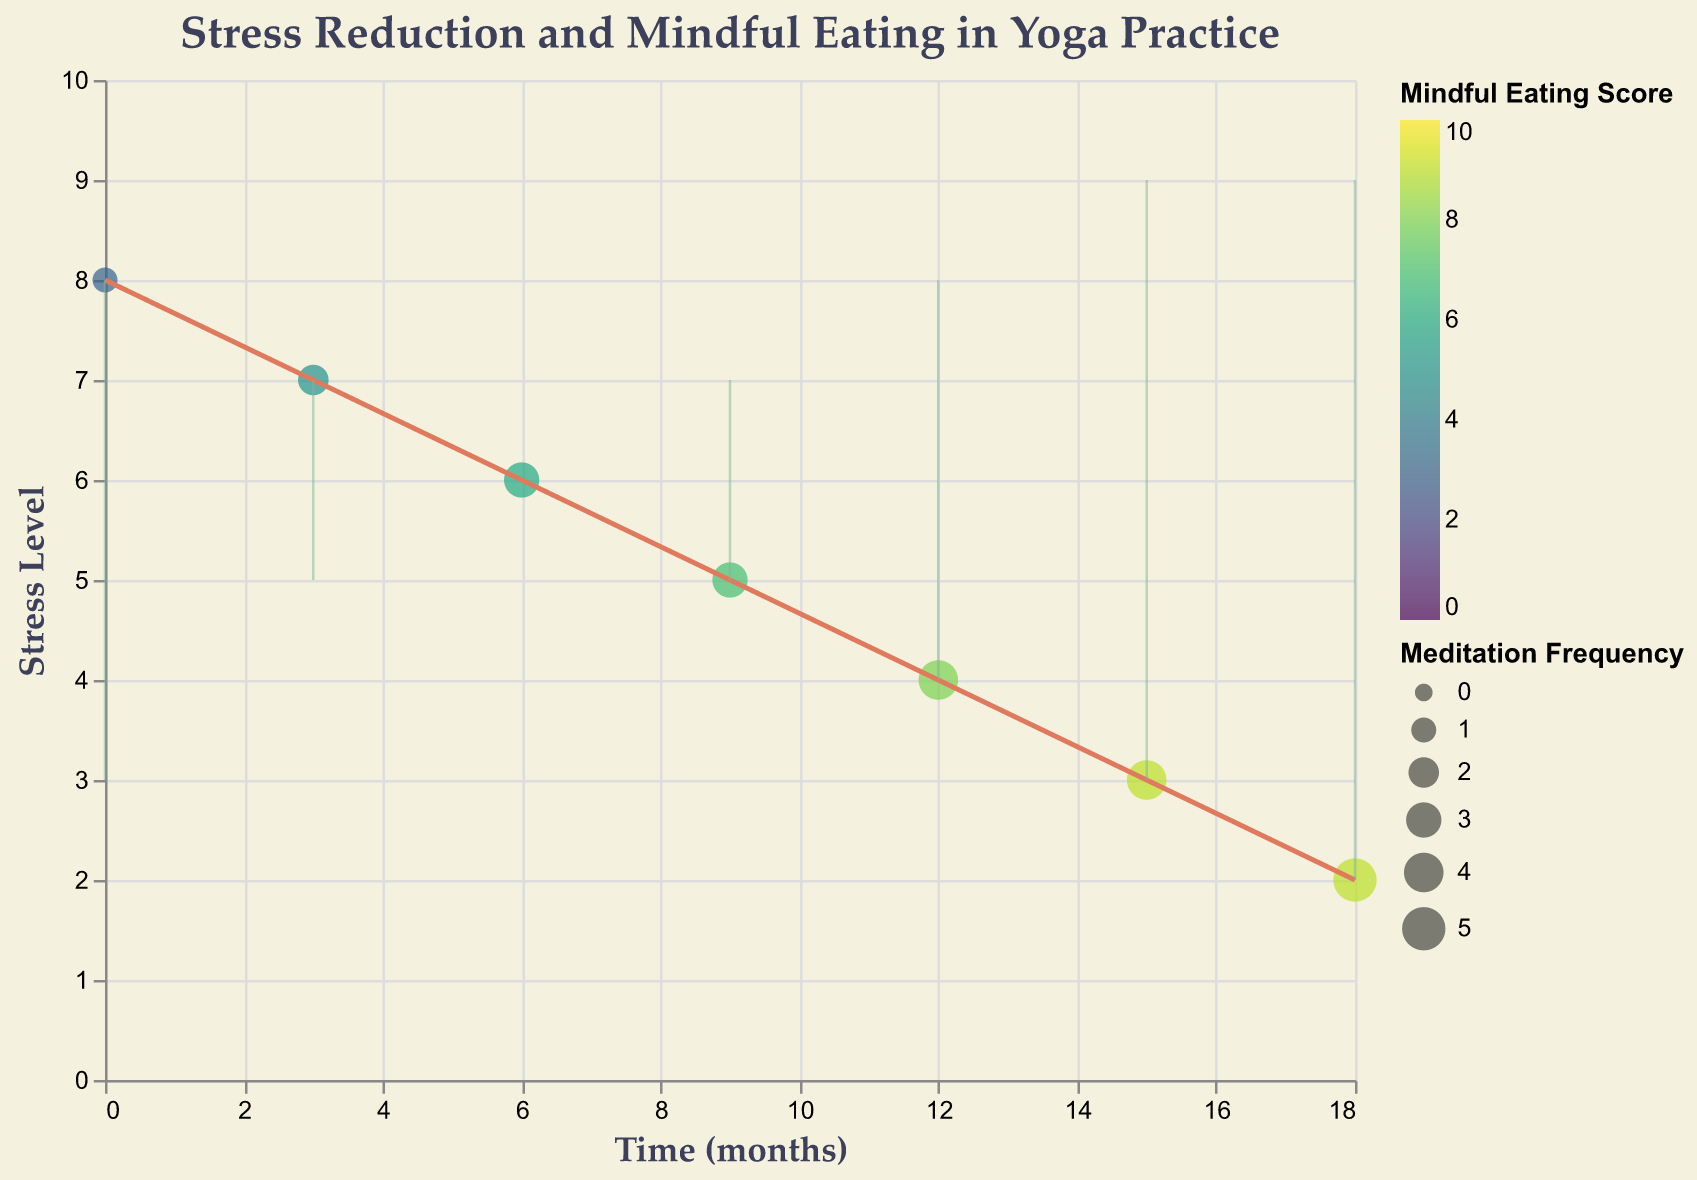How does the title describe the main focus of the figure? The title "Stress Reduction and Mindful Eating in Yoga Practice" indicates that the plot is about examining the relationship between stress reduction and mindful eating habits among yoga practitioners over time.
Answer: The relationship between stress reduction and mindful eating What is displayed along the x-axis? The x-axis represents the "Time (months)" over which the data was collected.
Answer: Time (months) What is the range of the stress level on the y-axis? The y-axis shows "Stress Level," ranging from 0 to 10 based on the axis labels.
Answer: 0 to 10 How does the color scheme relate to the Mindful Eating Score? The color scheme, ranging from lighter to darker shades, reflects the "Mindful Eating Score" from low to high, as per the legend.
Answer: It shows the Mindful Eating Score What does the size of the points indicate? The size of the points indicates the "Meditation Frequency (times/week)" with larger points representing higher frequency according to the legend.
Answer: Meditation Frequency Between which months did the stress level decrease the most significantly? The stress level dropped from 3 months (stress level 7) to 6 months (stress level 6), and from 12 months (stress level 4) to 15 months (stress level 3), both by 1 point each.
Answer: 3 to 6 months and 12 to 15 months How does the stress level at 18 months compare to the beginning (0 months)? At 18 months, the stress level is 2, which has significantly reduced from the stress level of 8 at 0 months.
Answer: 2 vs. 8 Which month had the highest Mindful Eating Score, and what was the corresponding stress level? At 15 and 18 months, the Mindful Eating Score was highest at 9, with corresponding stress levels of 3 and 2, respectively.
Answer: 15 and 18 months: Stress levels 3 and 2 What trend do you observe in the Cortisol Reduction percentage over time? The Cortisol Reduction percentage continuously increases over time, starting from 0% at 0 months to 40% at 18 months.
Answer: Continuous increase Over the 18 months, what overall change in meditation frequency is observed? The meditation frequency increased from 1 time per week at 0 months to 5 times per week at 18 months.
Answer: Increased from 1 to 5 times per week 